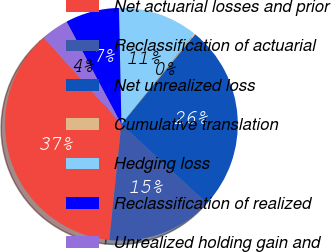Convert chart. <chart><loc_0><loc_0><loc_500><loc_500><pie_chart><fcel>Net actuarial losses and prior<fcel>Reclassification of actuarial<fcel>Net unrealized loss<fcel>Cumulative translation<fcel>Hedging loss<fcel>Reclassification of realized<fcel>Unrealized holding gain and<nl><fcel>36.72%<fcel>14.78%<fcel>25.94%<fcel>0.15%<fcel>11.12%<fcel>7.47%<fcel>3.81%<nl></chart> 